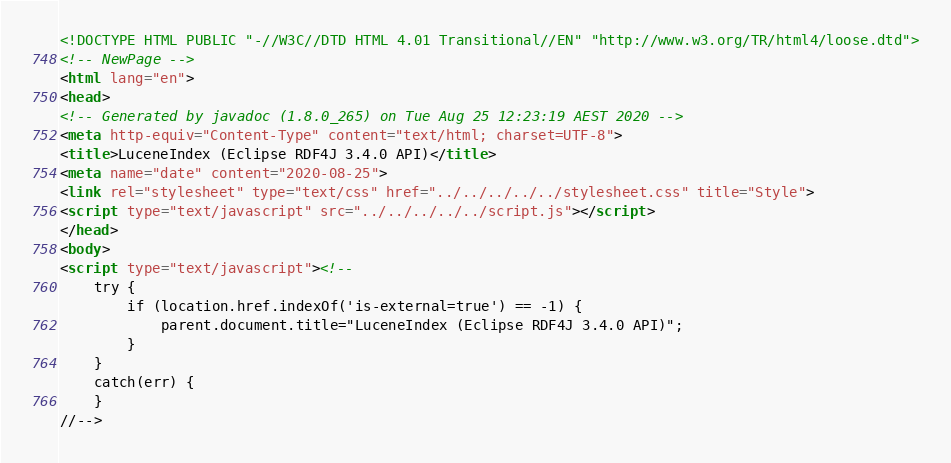Convert code to text. <code><loc_0><loc_0><loc_500><loc_500><_HTML_><!DOCTYPE HTML PUBLIC "-//W3C//DTD HTML 4.01 Transitional//EN" "http://www.w3.org/TR/html4/loose.dtd">
<!-- NewPage -->
<html lang="en">
<head>
<!-- Generated by javadoc (1.8.0_265) on Tue Aug 25 12:23:19 AEST 2020 -->
<meta http-equiv="Content-Type" content="text/html; charset=UTF-8">
<title>LuceneIndex (Eclipse RDF4J 3.4.0 API)</title>
<meta name="date" content="2020-08-25">
<link rel="stylesheet" type="text/css" href="../../../../../stylesheet.css" title="Style">
<script type="text/javascript" src="../../../../../script.js"></script>
</head>
<body>
<script type="text/javascript"><!--
    try {
        if (location.href.indexOf('is-external=true') == -1) {
            parent.document.title="LuceneIndex (Eclipse RDF4J 3.4.0 API)";
        }
    }
    catch(err) {
    }
//--></code> 